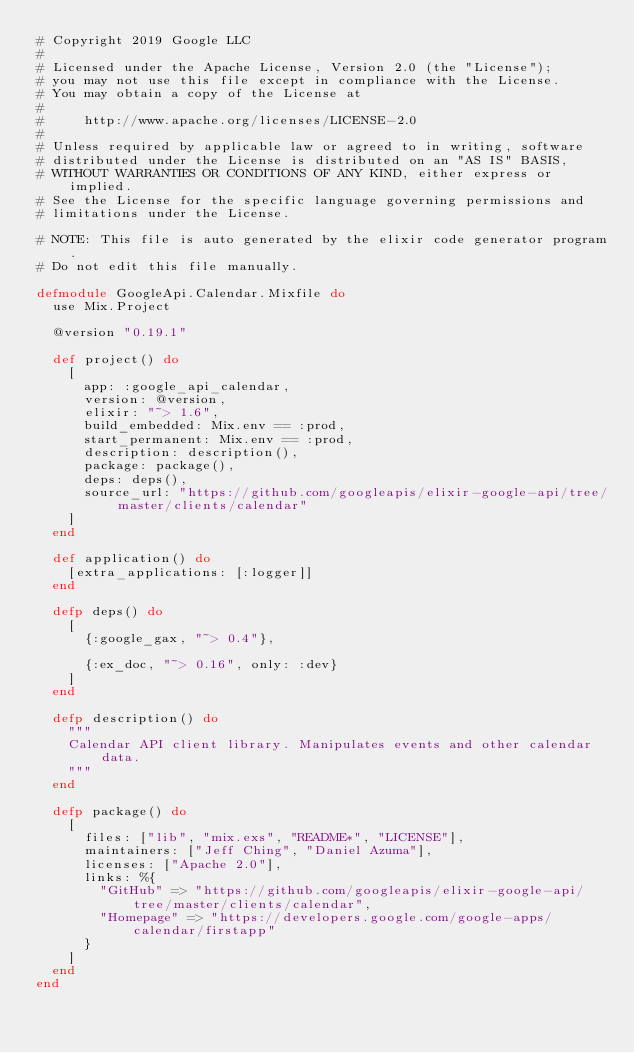<code> <loc_0><loc_0><loc_500><loc_500><_Elixir_># Copyright 2019 Google LLC
#
# Licensed under the Apache License, Version 2.0 (the "License");
# you may not use this file except in compliance with the License.
# You may obtain a copy of the License at
#
#     http://www.apache.org/licenses/LICENSE-2.0
#
# Unless required by applicable law or agreed to in writing, software
# distributed under the License is distributed on an "AS IS" BASIS,
# WITHOUT WARRANTIES OR CONDITIONS OF ANY KIND, either express or implied.
# See the License for the specific language governing permissions and
# limitations under the License.

# NOTE: This file is auto generated by the elixir code generator program.
# Do not edit this file manually.

defmodule GoogleApi.Calendar.Mixfile do
  use Mix.Project

  @version "0.19.1"

  def project() do
    [
      app: :google_api_calendar,
      version: @version,
      elixir: "~> 1.6",
      build_embedded: Mix.env == :prod,
      start_permanent: Mix.env == :prod,
      description: description(),
      package: package(),
      deps: deps(),
      source_url: "https://github.com/googleapis/elixir-google-api/tree/master/clients/calendar"
    ]
  end

  def application() do
    [extra_applications: [:logger]]
  end

  defp deps() do
    [
      {:google_gax, "~> 0.4"},

      {:ex_doc, "~> 0.16", only: :dev}
    ]
  end

  defp description() do
    """
    Calendar API client library. Manipulates events and other calendar data.
    """
  end

  defp package() do
    [
      files: ["lib", "mix.exs", "README*", "LICENSE"],
      maintainers: ["Jeff Ching", "Daniel Azuma"],
      licenses: ["Apache 2.0"],
      links: %{
        "GitHub" => "https://github.com/googleapis/elixir-google-api/tree/master/clients/calendar",
        "Homepage" => "https://developers.google.com/google-apps/calendar/firstapp"
      }
    ]
  end
end
</code> 